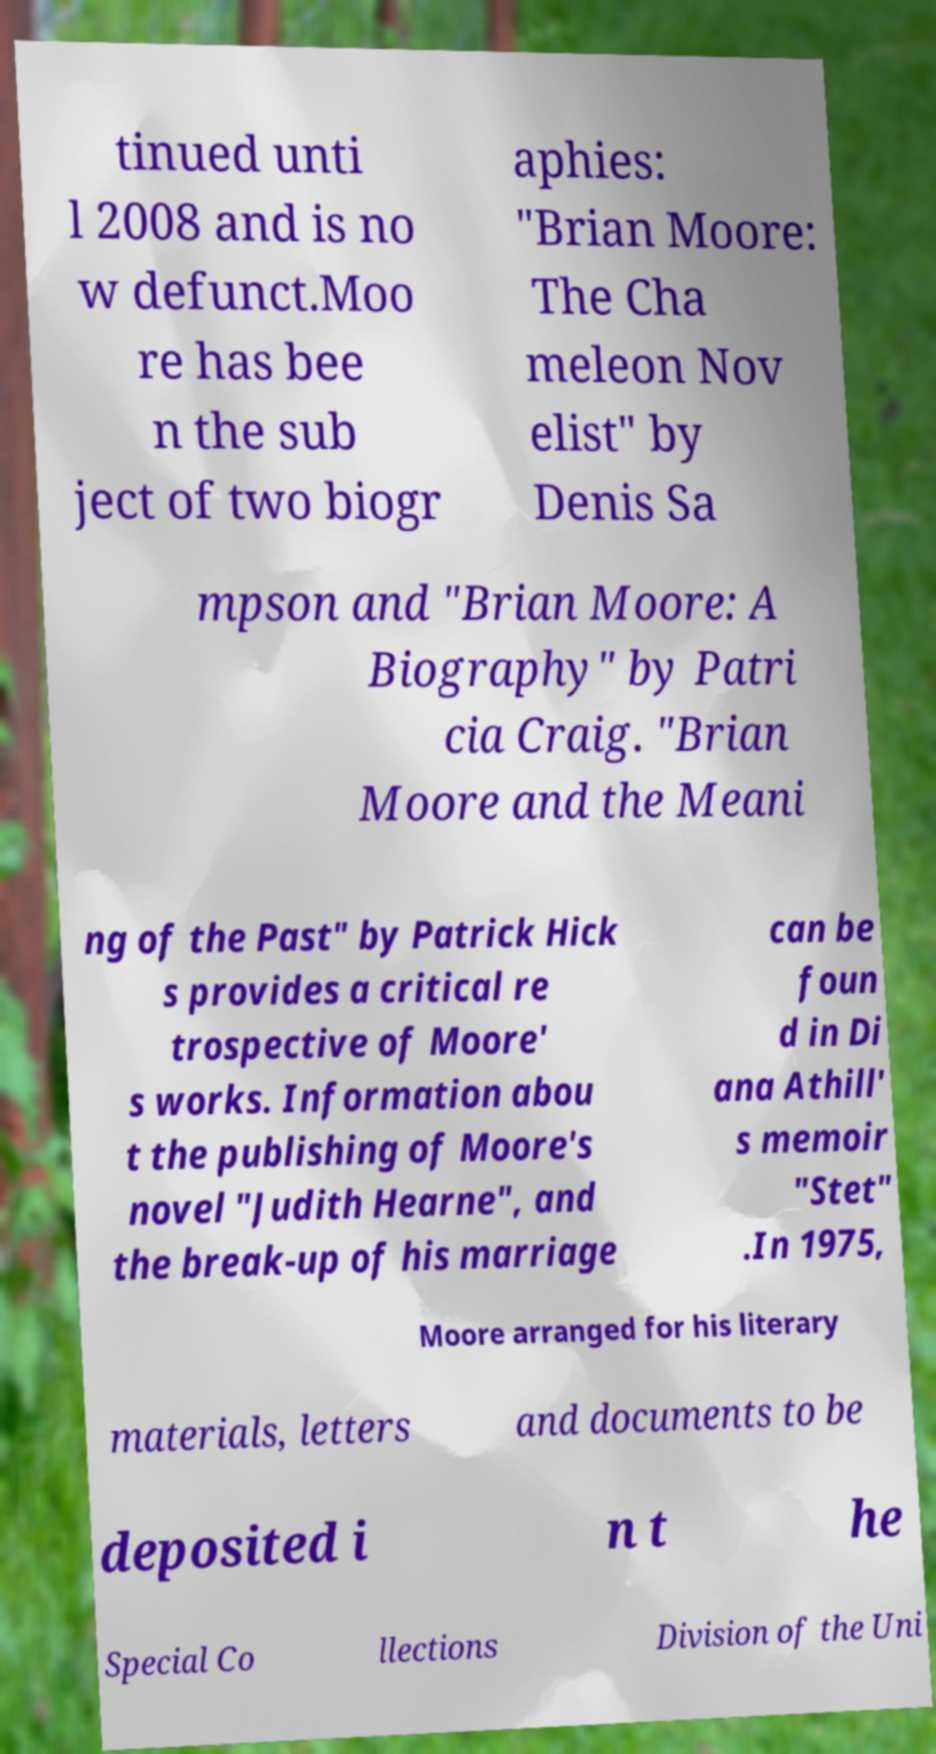For documentation purposes, I need the text within this image transcribed. Could you provide that? tinued unti l 2008 and is no w defunct.Moo re has bee n the sub ject of two biogr aphies: "Brian Moore: The Cha meleon Nov elist" by Denis Sa mpson and "Brian Moore: A Biography" by Patri cia Craig. "Brian Moore and the Meani ng of the Past" by Patrick Hick s provides a critical re trospective of Moore' s works. Information abou t the publishing of Moore's novel "Judith Hearne", and the break-up of his marriage can be foun d in Di ana Athill' s memoir "Stet" .In 1975, Moore arranged for his literary materials, letters and documents to be deposited i n t he Special Co llections Division of the Uni 